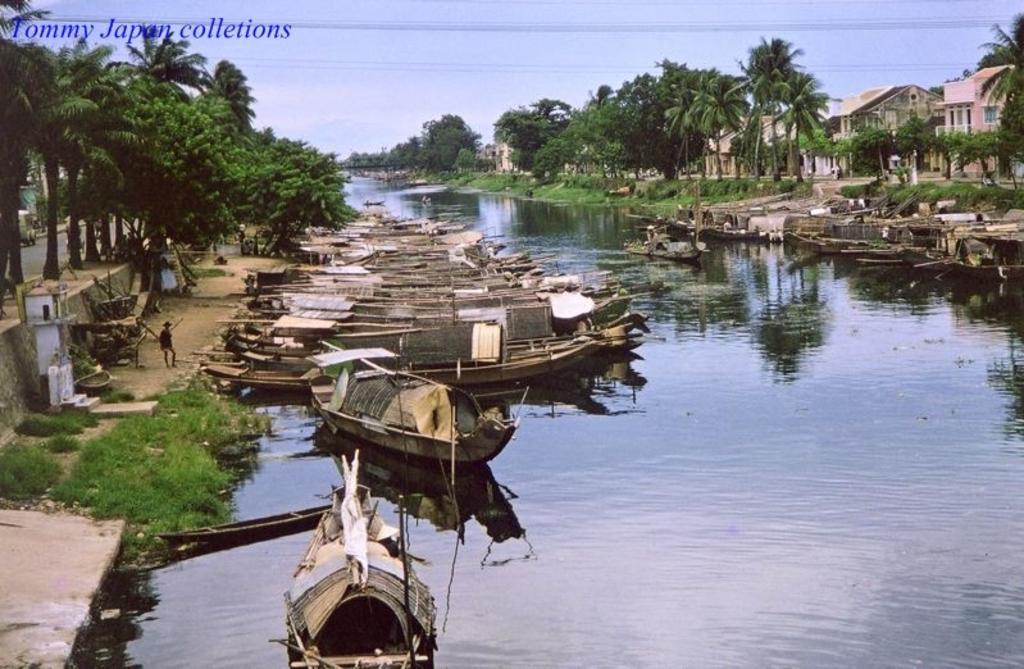How would you summarize this image in a sentence or two? In this image, we can see a canal in between trees. There are some boats floating on the water. There are buildings in the top right of the image. There is a sky at the top of the image. 